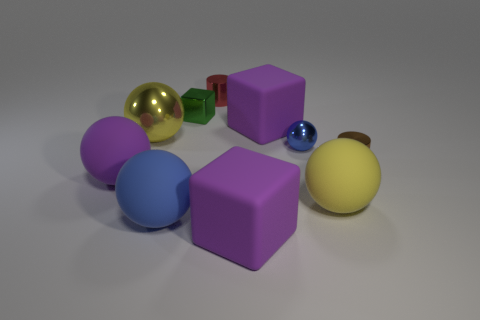Subtract all purple balls. How many balls are left? 4 Subtract all red cubes. How many blue balls are left? 2 Subtract all green cubes. How many cubes are left? 2 Subtract 1 cylinders. How many cylinders are left? 1 Add 8 brown metallic things. How many brown metallic things exist? 9 Subtract 1 red cylinders. How many objects are left? 9 Subtract all blocks. How many objects are left? 7 Subtract all cyan cylinders. Subtract all green balls. How many cylinders are left? 2 Subtract all big gray metallic cylinders. Subtract all small red cylinders. How many objects are left? 9 Add 4 metallic objects. How many metallic objects are left? 9 